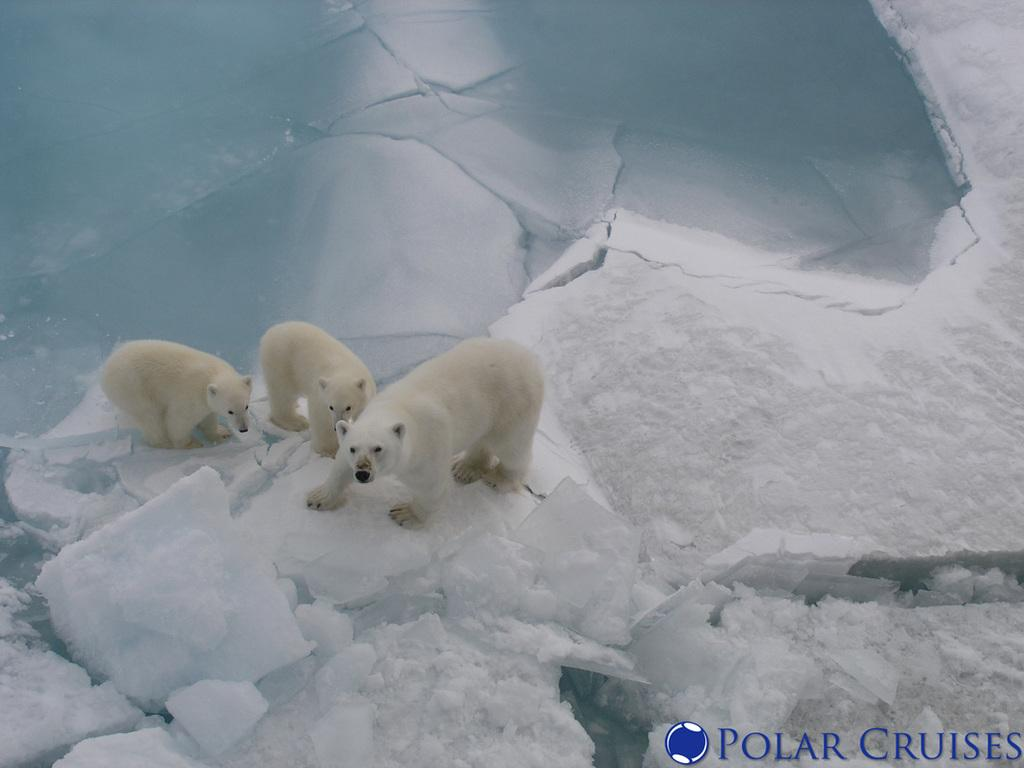What type of animals are in the image? There are polar bears in the image. What surface are the polar bears standing on? The polar bears are on the snow. What type of water is visible in the image? There is ice water visible in the image. What type of operation is being performed on the cattle in the image? There are no cattle or any operation being performed in the image; it features polar bears on the snow. Where might you find a bedroom in the image? There is no bedroom present in the image; it features polar bears on the snow. 